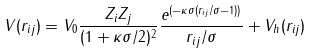Convert formula to latex. <formula><loc_0><loc_0><loc_500><loc_500>V ( r _ { i j } ) = V _ { 0 } \frac { Z _ { i } Z _ { j } } { ( 1 + \kappa \sigma / 2 ) ^ { 2 } } \frac { e ^ { ( - \kappa \sigma ( r _ { i j } / \sigma - 1 ) ) } } { r _ { i j } / \sigma } + V _ { h } ( r _ { i j } )</formula> 